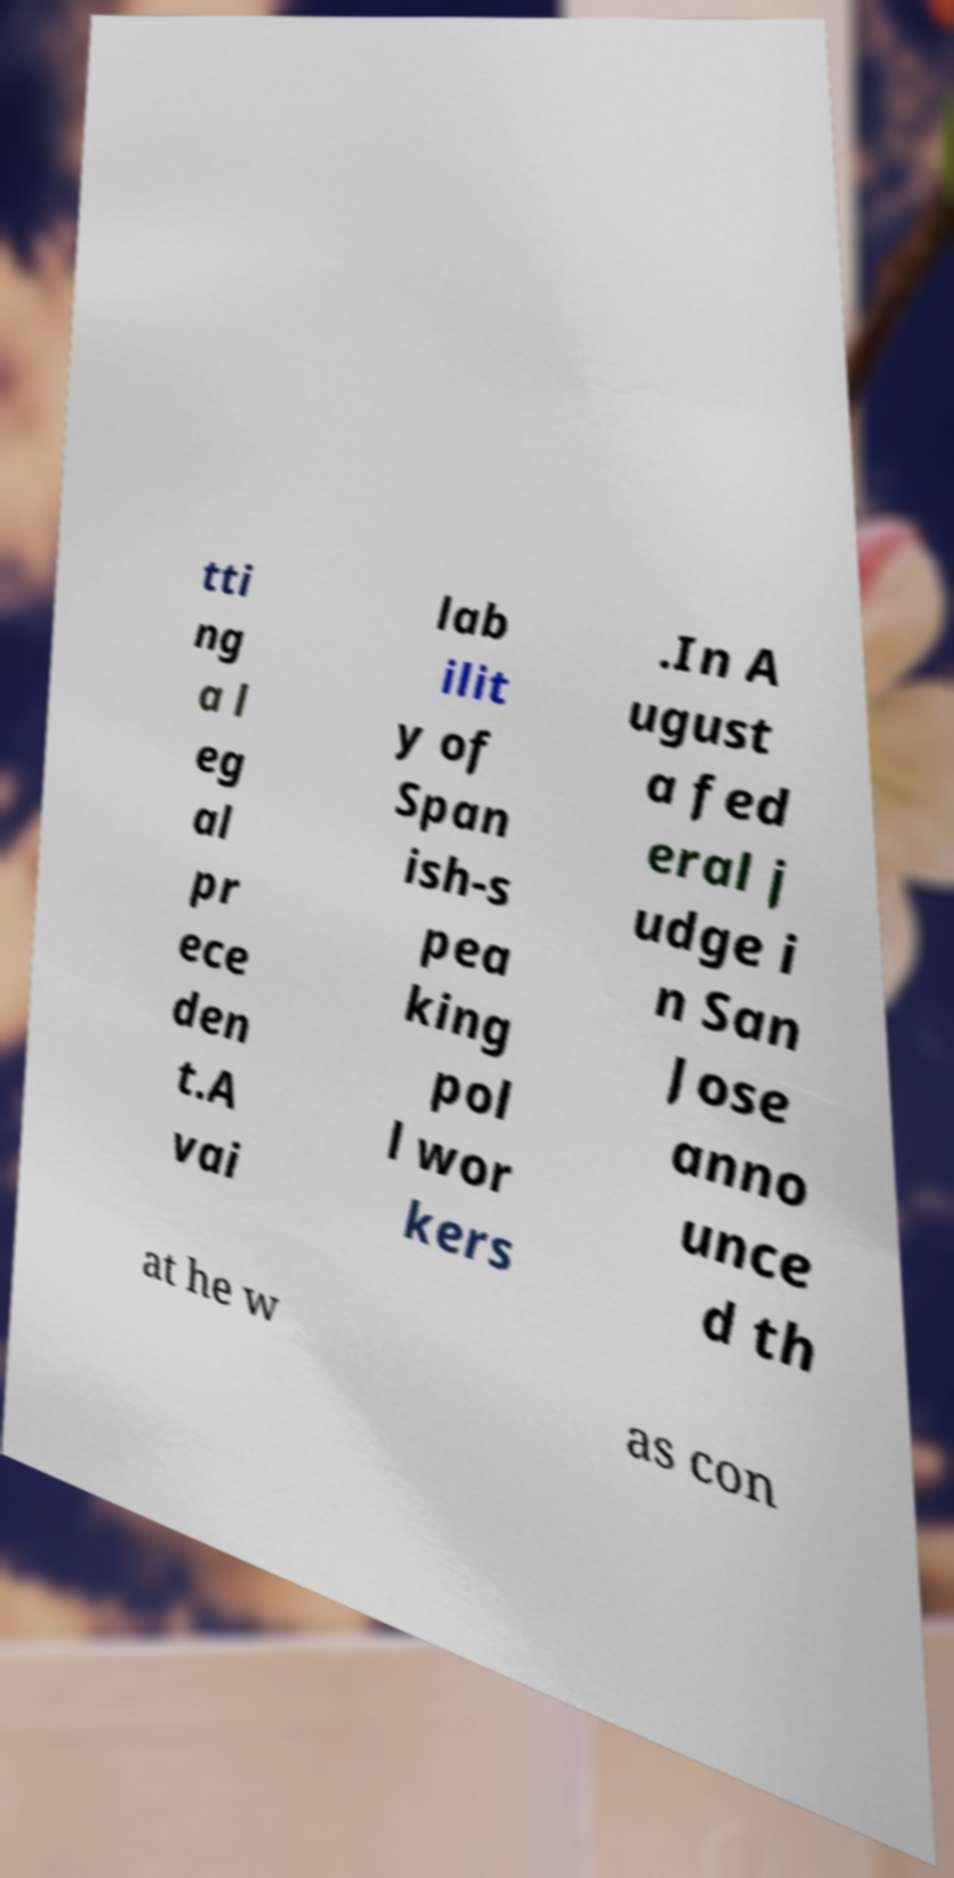For documentation purposes, I need the text within this image transcribed. Could you provide that? tti ng a l eg al pr ece den t.A vai lab ilit y of Span ish-s pea king pol l wor kers .In A ugust a fed eral j udge i n San Jose anno unce d th at he w as con 